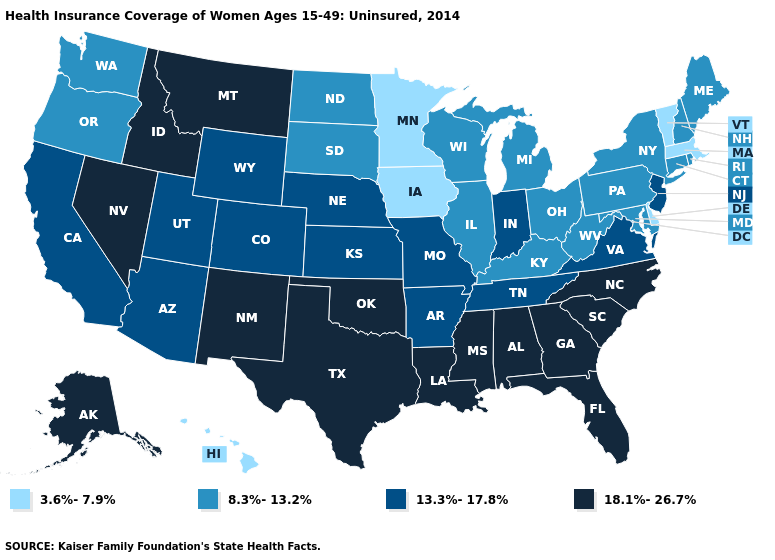Which states have the highest value in the USA?
Concise answer only. Alabama, Alaska, Florida, Georgia, Idaho, Louisiana, Mississippi, Montana, Nevada, New Mexico, North Carolina, Oklahoma, South Carolina, Texas. What is the value of Kansas?
Quick response, please. 13.3%-17.8%. Which states have the highest value in the USA?
Concise answer only. Alabama, Alaska, Florida, Georgia, Idaho, Louisiana, Mississippi, Montana, Nevada, New Mexico, North Carolina, Oklahoma, South Carolina, Texas. What is the value of Ohio?
Be succinct. 8.3%-13.2%. What is the value of Washington?
Be succinct. 8.3%-13.2%. What is the lowest value in the MidWest?
Short answer required. 3.6%-7.9%. Which states have the highest value in the USA?
Answer briefly. Alabama, Alaska, Florida, Georgia, Idaho, Louisiana, Mississippi, Montana, Nevada, New Mexico, North Carolina, Oklahoma, South Carolina, Texas. What is the value of California?
Keep it brief. 13.3%-17.8%. Among the states that border Alabama , does Georgia have the lowest value?
Answer briefly. No. Does Delaware have the lowest value in the USA?
Be succinct. Yes. Which states hav the highest value in the MidWest?
Answer briefly. Indiana, Kansas, Missouri, Nebraska. Among the states that border Utah , does Nevada have the highest value?
Short answer required. Yes. Does Minnesota have the same value as Connecticut?
Give a very brief answer. No. Is the legend a continuous bar?
Concise answer only. No. 